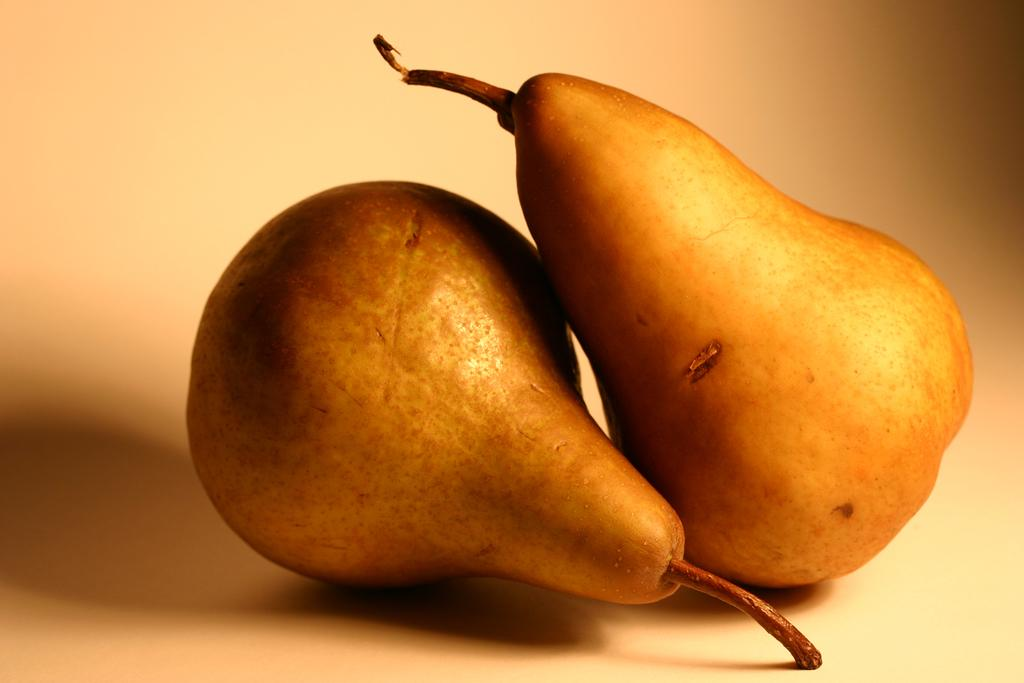What type of fruit is present in the image? There are pears in the image. What is the color of the surface on which the pears are placed? The pears are on a white surface. How many cobwebs can be seen in the image? There are no cobwebs present in the image. What is the amount of pears in the image? There is no text or numerical information in the image to determine the amount of pears. 